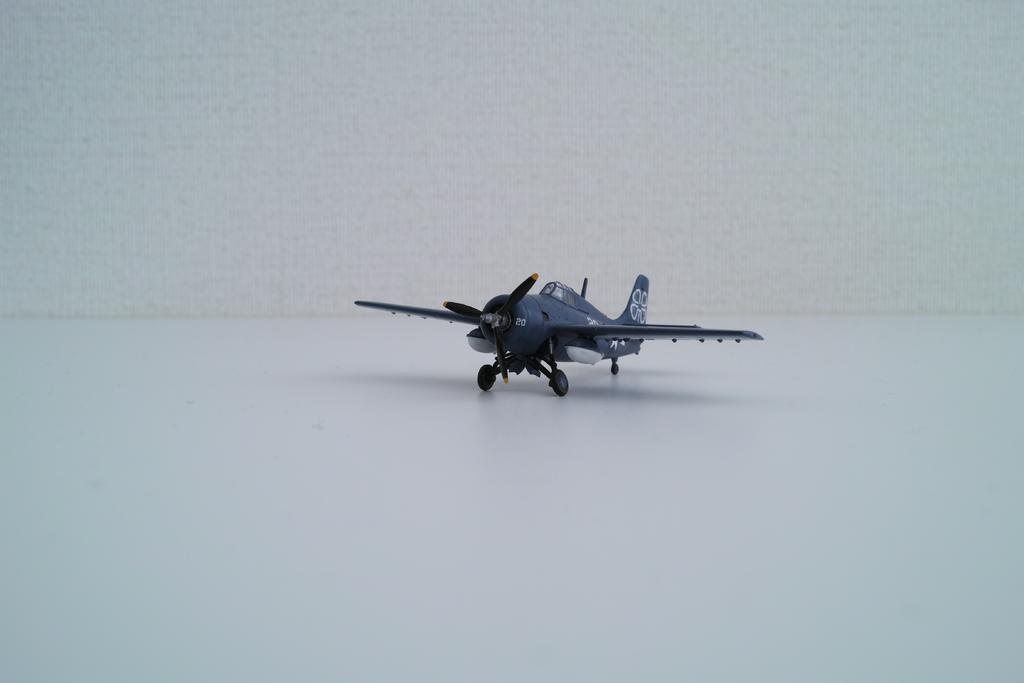What type of toy is present in the image? There is a toy aircraft in the image. Where is the kitty being held in the image? There is no kitty present in the image. 